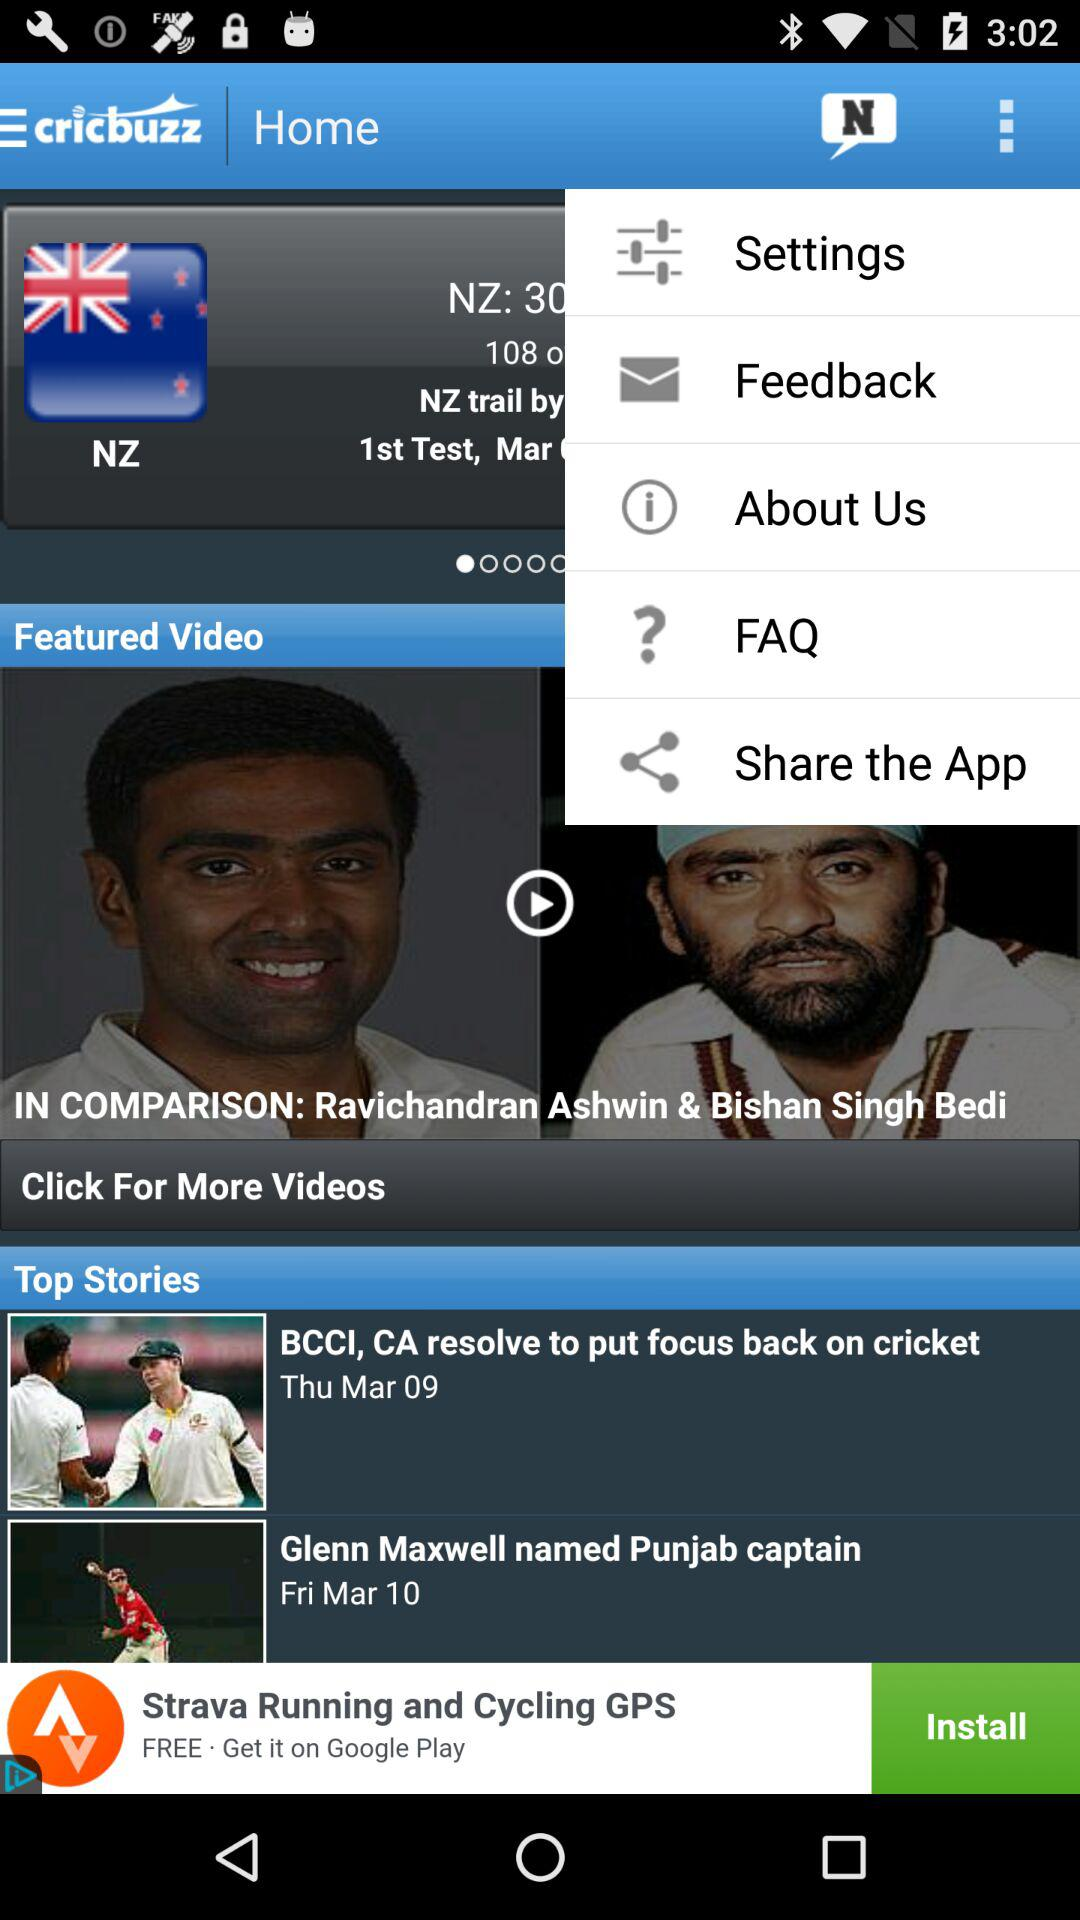On March 9, what news was updated? The updated news was "BCCI, CA resolve to put focus back on cricket". 